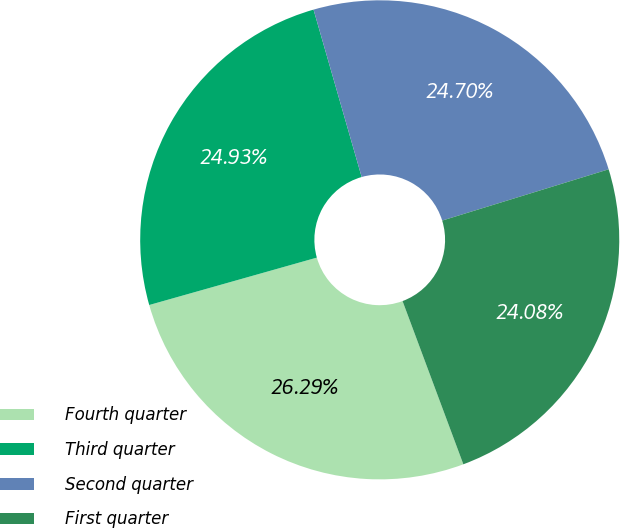<chart> <loc_0><loc_0><loc_500><loc_500><pie_chart><fcel>Fourth quarter<fcel>Third quarter<fcel>Second quarter<fcel>First quarter<nl><fcel>26.29%<fcel>24.93%<fcel>24.7%<fcel>24.08%<nl></chart> 